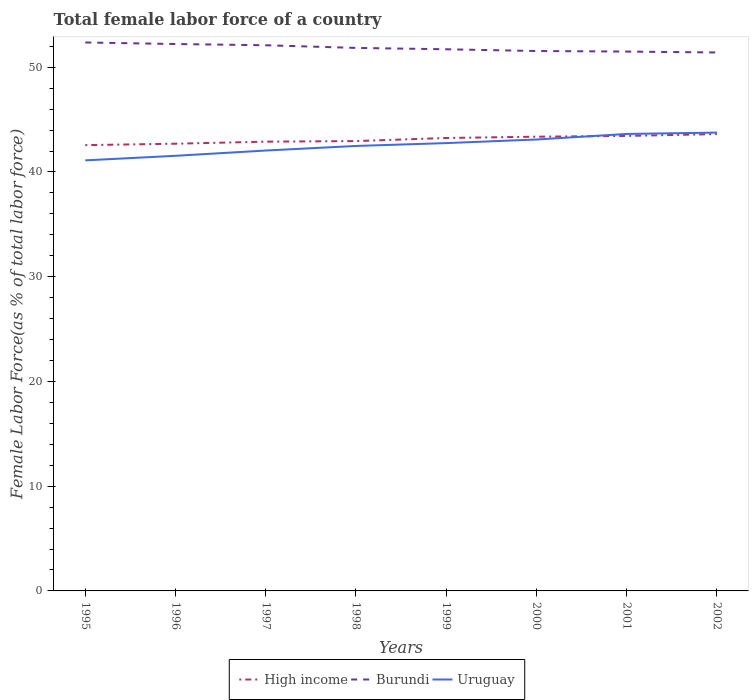How many different coloured lines are there?
Your response must be concise. 3. Does the line corresponding to Uruguay intersect with the line corresponding to High income?
Offer a very short reply. Yes. Across all years, what is the maximum percentage of female labor force in Uruguay?
Your answer should be very brief. 41.11. In which year was the percentage of female labor force in Uruguay maximum?
Offer a terse response. 1995. What is the total percentage of female labor force in High income in the graph?
Offer a terse response. -0.55. What is the difference between the highest and the second highest percentage of female labor force in Burundi?
Ensure brevity in your answer.  0.96. What is the difference between the highest and the lowest percentage of female labor force in Burundi?
Offer a very short reply. 4. Is the percentage of female labor force in Burundi strictly greater than the percentage of female labor force in Uruguay over the years?
Ensure brevity in your answer.  No. How many years are there in the graph?
Your response must be concise. 8. Are the values on the major ticks of Y-axis written in scientific E-notation?
Keep it short and to the point. No. Where does the legend appear in the graph?
Keep it short and to the point. Bottom center. How are the legend labels stacked?
Provide a short and direct response. Horizontal. What is the title of the graph?
Your answer should be compact. Total female labor force of a country. What is the label or title of the Y-axis?
Offer a terse response. Female Labor Force(as % of total labor force). What is the Female Labor Force(as % of total labor force) of High income in 1995?
Offer a very short reply. 42.57. What is the Female Labor Force(as % of total labor force) of Burundi in 1995?
Keep it short and to the point. 52.37. What is the Female Labor Force(as % of total labor force) in Uruguay in 1995?
Give a very brief answer. 41.11. What is the Female Labor Force(as % of total labor force) in High income in 1996?
Offer a very short reply. 42.7. What is the Female Labor Force(as % of total labor force) of Burundi in 1996?
Offer a very short reply. 52.22. What is the Female Labor Force(as % of total labor force) in Uruguay in 1996?
Keep it short and to the point. 41.55. What is the Female Labor Force(as % of total labor force) of High income in 1997?
Offer a terse response. 42.9. What is the Female Labor Force(as % of total labor force) in Burundi in 1997?
Provide a short and direct response. 52.1. What is the Female Labor Force(as % of total labor force) in Uruguay in 1997?
Offer a very short reply. 42.05. What is the Female Labor Force(as % of total labor force) in High income in 1998?
Your answer should be very brief. 42.95. What is the Female Labor Force(as % of total labor force) of Burundi in 1998?
Ensure brevity in your answer.  51.85. What is the Female Labor Force(as % of total labor force) of Uruguay in 1998?
Make the answer very short. 42.49. What is the Female Labor Force(as % of total labor force) of High income in 1999?
Offer a terse response. 43.25. What is the Female Labor Force(as % of total labor force) in Burundi in 1999?
Ensure brevity in your answer.  51.72. What is the Female Labor Force(as % of total labor force) of Uruguay in 1999?
Your answer should be compact. 42.76. What is the Female Labor Force(as % of total labor force) of High income in 2000?
Make the answer very short. 43.37. What is the Female Labor Force(as % of total labor force) in Burundi in 2000?
Provide a short and direct response. 51.55. What is the Female Labor Force(as % of total labor force) of Uruguay in 2000?
Provide a succinct answer. 43.1. What is the Female Labor Force(as % of total labor force) of High income in 2001?
Give a very brief answer. 43.44. What is the Female Labor Force(as % of total labor force) of Burundi in 2001?
Provide a short and direct response. 51.5. What is the Female Labor Force(as % of total labor force) in Uruguay in 2001?
Give a very brief answer. 43.63. What is the Female Labor Force(as % of total labor force) of High income in 2002?
Your answer should be very brief. 43.62. What is the Female Labor Force(as % of total labor force) of Burundi in 2002?
Offer a terse response. 51.41. What is the Female Labor Force(as % of total labor force) of Uruguay in 2002?
Offer a terse response. 43.76. Across all years, what is the maximum Female Labor Force(as % of total labor force) of High income?
Your answer should be very brief. 43.62. Across all years, what is the maximum Female Labor Force(as % of total labor force) in Burundi?
Your answer should be compact. 52.37. Across all years, what is the maximum Female Labor Force(as % of total labor force) in Uruguay?
Make the answer very short. 43.76. Across all years, what is the minimum Female Labor Force(as % of total labor force) in High income?
Offer a terse response. 42.57. Across all years, what is the minimum Female Labor Force(as % of total labor force) in Burundi?
Your answer should be compact. 51.41. Across all years, what is the minimum Female Labor Force(as % of total labor force) in Uruguay?
Your response must be concise. 41.11. What is the total Female Labor Force(as % of total labor force) of High income in the graph?
Make the answer very short. 344.8. What is the total Female Labor Force(as % of total labor force) in Burundi in the graph?
Provide a short and direct response. 414.72. What is the total Female Labor Force(as % of total labor force) of Uruguay in the graph?
Ensure brevity in your answer.  340.45. What is the difference between the Female Labor Force(as % of total labor force) in High income in 1995 and that in 1996?
Make the answer very short. -0.14. What is the difference between the Female Labor Force(as % of total labor force) of Burundi in 1995 and that in 1996?
Provide a short and direct response. 0.15. What is the difference between the Female Labor Force(as % of total labor force) of Uruguay in 1995 and that in 1996?
Offer a very short reply. -0.44. What is the difference between the Female Labor Force(as % of total labor force) in High income in 1995 and that in 1997?
Provide a short and direct response. -0.33. What is the difference between the Female Labor Force(as % of total labor force) in Burundi in 1995 and that in 1997?
Provide a succinct answer. 0.27. What is the difference between the Female Labor Force(as % of total labor force) of Uruguay in 1995 and that in 1997?
Provide a short and direct response. -0.94. What is the difference between the Female Labor Force(as % of total labor force) in High income in 1995 and that in 1998?
Provide a short and direct response. -0.39. What is the difference between the Female Labor Force(as % of total labor force) in Burundi in 1995 and that in 1998?
Provide a succinct answer. 0.52. What is the difference between the Female Labor Force(as % of total labor force) of Uruguay in 1995 and that in 1998?
Offer a very short reply. -1.38. What is the difference between the Female Labor Force(as % of total labor force) in High income in 1995 and that in 1999?
Offer a very short reply. -0.68. What is the difference between the Female Labor Force(as % of total labor force) of Burundi in 1995 and that in 1999?
Keep it short and to the point. 0.65. What is the difference between the Female Labor Force(as % of total labor force) in Uruguay in 1995 and that in 1999?
Provide a short and direct response. -1.65. What is the difference between the Female Labor Force(as % of total labor force) of High income in 1995 and that in 2000?
Make the answer very short. -0.81. What is the difference between the Female Labor Force(as % of total labor force) of Burundi in 1995 and that in 2000?
Offer a terse response. 0.82. What is the difference between the Female Labor Force(as % of total labor force) in Uruguay in 1995 and that in 2000?
Make the answer very short. -1.99. What is the difference between the Female Labor Force(as % of total labor force) in High income in 1995 and that in 2001?
Keep it short and to the point. -0.88. What is the difference between the Female Labor Force(as % of total labor force) of Burundi in 1995 and that in 2001?
Ensure brevity in your answer.  0.87. What is the difference between the Female Labor Force(as % of total labor force) of Uruguay in 1995 and that in 2001?
Provide a short and direct response. -2.52. What is the difference between the Female Labor Force(as % of total labor force) in High income in 1995 and that in 2002?
Offer a terse response. -1.05. What is the difference between the Female Labor Force(as % of total labor force) of Burundi in 1995 and that in 2002?
Keep it short and to the point. 0.96. What is the difference between the Female Labor Force(as % of total labor force) in Uruguay in 1995 and that in 2002?
Keep it short and to the point. -2.65. What is the difference between the Female Labor Force(as % of total labor force) in High income in 1996 and that in 1997?
Offer a terse response. -0.2. What is the difference between the Female Labor Force(as % of total labor force) in Burundi in 1996 and that in 1997?
Make the answer very short. 0.12. What is the difference between the Female Labor Force(as % of total labor force) in Uruguay in 1996 and that in 1997?
Your answer should be compact. -0.5. What is the difference between the Female Labor Force(as % of total labor force) in High income in 1996 and that in 1998?
Make the answer very short. -0.25. What is the difference between the Female Labor Force(as % of total labor force) of Burundi in 1996 and that in 1998?
Offer a very short reply. 0.37. What is the difference between the Female Labor Force(as % of total labor force) of Uruguay in 1996 and that in 1998?
Offer a very short reply. -0.94. What is the difference between the Female Labor Force(as % of total labor force) in High income in 1996 and that in 1999?
Offer a terse response. -0.55. What is the difference between the Female Labor Force(as % of total labor force) in Burundi in 1996 and that in 1999?
Your answer should be very brief. 0.5. What is the difference between the Female Labor Force(as % of total labor force) in Uruguay in 1996 and that in 1999?
Offer a very short reply. -1.21. What is the difference between the Female Labor Force(as % of total labor force) in High income in 1996 and that in 2000?
Ensure brevity in your answer.  -0.67. What is the difference between the Female Labor Force(as % of total labor force) of Burundi in 1996 and that in 2000?
Your answer should be very brief. 0.67. What is the difference between the Female Labor Force(as % of total labor force) in Uruguay in 1996 and that in 2000?
Offer a terse response. -1.56. What is the difference between the Female Labor Force(as % of total labor force) in High income in 1996 and that in 2001?
Your answer should be very brief. -0.74. What is the difference between the Female Labor Force(as % of total labor force) of Burundi in 1996 and that in 2001?
Your response must be concise. 0.72. What is the difference between the Female Labor Force(as % of total labor force) in Uruguay in 1996 and that in 2001?
Provide a succinct answer. -2.09. What is the difference between the Female Labor Force(as % of total labor force) of High income in 1996 and that in 2002?
Ensure brevity in your answer.  -0.92. What is the difference between the Female Labor Force(as % of total labor force) in Burundi in 1996 and that in 2002?
Your answer should be very brief. 0.81. What is the difference between the Female Labor Force(as % of total labor force) of Uruguay in 1996 and that in 2002?
Give a very brief answer. -2.22. What is the difference between the Female Labor Force(as % of total labor force) of High income in 1997 and that in 1998?
Your answer should be compact. -0.06. What is the difference between the Female Labor Force(as % of total labor force) of Burundi in 1997 and that in 1998?
Your answer should be compact. 0.25. What is the difference between the Female Labor Force(as % of total labor force) of Uruguay in 1997 and that in 1998?
Provide a succinct answer. -0.44. What is the difference between the Female Labor Force(as % of total labor force) in High income in 1997 and that in 1999?
Keep it short and to the point. -0.35. What is the difference between the Female Labor Force(as % of total labor force) in Burundi in 1997 and that in 1999?
Give a very brief answer. 0.38. What is the difference between the Female Labor Force(as % of total labor force) of Uruguay in 1997 and that in 1999?
Your answer should be compact. -0.71. What is the difference between the Female Labor Force(as % of total labor force) in High income in 1997 and that in 2000?
Ensure brevity in your answer.  -0.47. What is the difference between the Female Labor Force(as % of total labor force) in Burundi in 1997 and that in 2000?
Make the answer very short. 0.55. What is the difference between the Female Labor Force(as % of total labor force) in Uruguay in 1997 and that in 2000?
Provide a short and direct response. -1.05. What is the difference between the Female Labor Force(as % of total labor force) of High income in 1997 and that in 2001?
Provide a succinct answer. -0.55. What is the difference between the Female Labor Force(as % of total labor force) of Burundi in 1997 and that in 2001?
Ensure brevity in your answer.  0.6. What is the difference between the Female Labor Force(as % of total labor force) of Uruguay in 1997 and that in 2001?
Provide a succinct answer. -1.58. What is the difference between the Female Labor Force(as % of total labor force) in High income in 1997 and that in 2002?
Provide a short and direct response. -0.72. What is the difference between the Female Labor Force(as % of total labor force) of Burundi in 1997 and that in 2002?
Provide a short and direct response. 0.69. What is the difference between the Female Labor Force(as % of total labor force) in Uruguay in 1997 and that in 2002?
Give a very brief answer. -1.71. What is the difference between the Female Labor Force(as % of total labor force) of High income in 1998 and that in 1999?
Your answer should be compact. -0.3. What is the difference between the Female Labor Force(as % of total labor force) in Burundi in 1998 and that in 1999?
Offer a very short reply. 0.13. What is the difference between the Female Labor Force(as % of total labor force) in Uruguay in 1998 and that in 1999?
Offer a terse response. -0.27. What is the difference between the Female Labor Force(as % of total labor force) of High income in 1998 and that in 2000?
Your answer should be very brief. -0.42. What is the difference between the Female Labor Force(as % of total labor force) of Burundi in 1998 and that in 2000?
Your answer should be very brief. 0.3. What is the difference between the Female Labor Force(as % of total labor force) of Uruguay in 1998 and that in 2000?
Your response must be concise. -0.62. What is the difference between the Female Labor Force(as % of total labor force) in High income in 1998 and that in 2001?
Offer a very short reply. -0.49. What is the difference between the Female Labor Force(as % of total labor force) of Burundi in 1998 and that in 2001?
Offer a terse response. 0.35. What is the difference between the Female Labor Force(as % of total labor force) of Uruguay in 1998 and that in 2001?
Provide a short and direct response. -1.15. What is the difference between the Female Labor Force(as % of total labor force) in High income in 1998 and that in 2002?
Provide a short and direct response. -0.67. What is the difference between the Female Labor Force(as % of total labor force) in Burundi in 1998 and that in 2002?
Provide a short and direct response. 0.44. What is the difference between the Female Labor Force(as % of total labor force) of Uruguay in 1998 and that in 2002?
Your response must be concise. -1.28. What is the difference between the Female Labor Force(as % of total labor force) in High income in 1999 and that in 2000?
Keep it short and to the point. -0.12. What is the difference between the Female Labor Force(as % of total labor force) of Burundi in 1999 and that in 2000?
Offer a very short reply. 0.17. What is the difference between the Female Labor Force(as % of total labor force) in Uruguay in 1999 and that in 2000?
Keep it short and to the point. -0.34. What is the difference between the Female Labor Force(as % of total labor force) of High income in 1999 and that in 2001?
Your answer should be compact. -0.2. What is the difference between the Female Labor Force(as % of total labor force) in Burundi in 1999 and that in 2001?
Provide a short and direct response. 0.22. What is the difference between the Female Labor Force(as % of total labor force) in Uruguay in 1999 and that in 2001?
Provide a succinct answer. -0.87. What is the difference between the Female Labor Force(as % of total labor force) in High income in 1999 and that in 2002?
Your response must be concise. -0.37. What is the difference between the Female Labor Force(as % of total labor force) in Burundi in 1999 and that in 2002?
Your answer should be very brief. 0.31. What is the difference between the Female Labor Force(as % of total labor force) of Uruguay in 1999 and that in 2002?
Keep it short and to the point. -1. What is the difference between the Female Labor Force(as % of total labor force) in High income in 2000 and that in 2001?
Your response must be concise. -0.07. What is the difference between the Female Labor Force(as % of total labor force) of Burundi in 2000 and that in 2001?
Give a very brief answer. 0.05. What is the difference between the Female Labor Force(as % of total labor force) in Uruguay in 2000 and that in 2001?
Your response must be concise. -0.53. What is the difference between the Female Labor Force(as % of total labor force) in High income in 2000 and that in 2002?
Your answer should be compact. -0.25. What is the difference between the Female Labor Force(as % of total labor force) in Burundi in 2000 and that in 2002?
Provide a short and direct response. 0.14. What is the difference between the Female Labor Force(as % of total labor force) of Uruguay in 2000 and that in 2002?
Provide a succinct answer. -0.66. What is the difference between the Female Labor Force(as % of total labor force) in High income in 2001 and that in 2002?
Your answer should be very brief. -0.18. What is the difference between the Female Labor Force(as % of total labor force) in Burundi in 2001 and that in 2002?
Offer a terse response. 0.09. What is the difference between the Female Labor Force(as % of total labor force) in Uruguay in 2001 and that in 2002?
Your answer should be very brief. -0.13. What is the difference between the Female Labor Force(as % of total labor force) in High income in 1995 and the Female Labor Force(as % of total labor force) in Burundi in 1996?
Provide a succinct answer. -9.65. What is the difference between the Female Labor Force(as % of total labor force) in High income in 1995 and the Female Labor Force(as % of total labor force) in Uruguay in 1996?
Give a very brief answer. 1.02. What is the difference between the Female Labor Force(as % of total labor force) in Burundi in 1995 and the Female Labor Force(as % of total labor force) in Uruguay in 1996?
Your answer should be very brief. 10.82. What is the difference between the Female Labor Force(as % of total labor force) of High income in 1995 and the Female Labor Force(as % of total labor force) of Burundi in 1997?
Make the answer very short. -9.54. What is the difference between the Female Labor Force(as % of total labor force) of High income in 1995 and the Female Labor Force(as % of total labor force) of Uruguay in 1997?
Ensure brevity in your answer.  0.52. What is the difference between the Female Labor Force(as % of total labor force) in Burundi in 1995 and the Female Labor Force(as % of total labor force) in Uruguay in 1997?
Provide a short and direct response. 10.32. What is the difference between the Female Labor Force(as % of total labor force) of High income in 1995 and the Female Labor Force(as % of total labor force) of Burundi in 1998?
Keep it short and to the point. -9.28. What is the difference between the Female Labor Force(as % of total labor force) of High income in 1995 and the Female Labor Force(as % of total labor force) of Uruguay in 1998?
Offer a terse response. 0.08. What is the difference between the Female Labor Force(as % of total labor force) in Burundi in 1995 and the Female Labor Force(as % of total labor force) in Uruguay in 1998?
Keep it short and to the point. 9.88. What is the difference between the Female Labor Force(as % of total labor force) of High income in 1995 and the Female Labor Force(as % of total labor force) of Burundi in 1999?
Keep it short and to the point. -9.15. What is the difference between the Female Labor Force(as % of total labor force) of High income in 1995 and the Female Labor Force(as % of total labor force) of Uruguay in 1999?
Give a very brief answer. -0.19. What is the difference between the Female Labor Force(as % of total labor force) in Burundi in 1995 and the Female Labor Force(as % of total labor force) in Uruguay in 1999?
Your answer should be very brief. 9.61. What is the difference between the Female Labor Force(as % of total labor force) in High income in 1995 and the Female Labor Force(as % of total labor force) in Burundi in 2000?
Provide a short and direct response. -8.99. What is the difference between the Female Labor Force(as % of total labor force) of High income in 1995 and the Female Labor Force(as % of total labor force) of Uruguay in 2000?
Your answer should be very brief. -0.54. What is the difference between the Female Labor Force(as % of total labor force) of Burundi in 1995 and the Female Labor Force(as % of total labor force) of Uruguay in 2000?
Offer a very short reply. 9.26. What is the difference between the Female Labor Force(as % of total labor force) in High income in 1995 and the Female Labor Force(as % of total labor force) in Burundi in 2001?
Ensure brevity in your answer.  -8.93. What is the difference between the Female Labor Force(as % of total labor force) in High income in 1995 and the Female Labor Force(as % of total labor force) in Uruguay in 2001?
Provide a succinct answer. -1.07. What is the difference between the Female Labor Force(as % of total labor force) in Burundi in 1995 and the Female Labor Force(as % of total labor force) in Uruguay in 2001?
Ensure brevity in your answer.  8.73. What is the difference between the Female Labor Force(as % of total labor force) of High income in 1995 and the Female Labor Force(as % of total labor force) of Burundi in 2002?
Your response must be concise. -8.85. What is the difference between the Female Labor Force(as % of total labor force) in High income in 1995 and the Female Labor Force(as % of total labor force) in Uruguay in 2002?
Make the answer very short. -1.2. What is the difference between the Female Labor Force(as % of total labor force) in Burundi in 1995 and the Female Labor Force(as % of total labor force) in Uruguay in 2002?
Provide a short and direct response. 8.61. What is the difference between the Female Labor Force(as % of total labor force) in High income in 1996 and the Female Labor Force(as % of total labor force) in Burundi in 1997?
Keep it short and to the point. -9.4. What is the difference between the Female Labor Force(as % of total labor force) in High income in 1996 and the Female Labor Force(as % of total labor force) in Uruguay in 1997?
Your answer should be very brief. 0.65. What is the difference between the Female Labor Force(as % of total labor force) of Burundi in 1996 and the Female Labor Force(as % of total labor force) of Uruguay in 1997?
Your answer should be very brief. 10.17. What is the difference between the Female Labor Force(as % of total labor force) in High income in 1996 and the Female Labor Force(as % of total labor force) in Burundi in 1998?
Offer a terse response. -9.15. What is the difference between the Female Labor Force(as % of total labor force) of High income in 1996 and the Female Labor Force(as % of total labor force) of Uruguay in 1998?
Your response must be concise. 0.21. What is the difference between the Female Labor Force(as % of total labor force) of Burundi in 1996 and the Female Labor Force(as % of total labor force) of Uruguay in 1998?
Keep it short and to the point. 9.73. What is the difference between the Female Labor Force(as % of total labor force) of High income in 1996 and the Female Labor Force(as % of total labor force) of Burundi in 1999?
Offer a very short reply. -9.02. What is the difference between the Female Labor Force(as % of total labor force) in High income in 1996 and the Female Labor Force(as % of total labor force) in Uruguay in 1999?
Your answer should be compact. -0.06. What is the difference between the Female Labor Force(as % of total labor force) of Burundi in 1996 and the Female Labor Force(as % of total labor force) of Uruguay in 1999?
Your answer should be very brief. 9.46. What is the difference between the Female Labor Force(as % of total labor force) in High income in 1996 and the Female Labor Force(as % of total labor force) in Burundi in 2000?
Ensure brevity in your answer.  -8.85. What is the difference between the Female Labor Force(as % of total labor force) in High income in 1996 and the Female Labor Force(as % of total labor force) in Uruguay in 2000?
Offer a very short reply. -0.4. What is the difference between the Female Labor Force(as % of total labor force) of Burundi in 1996 and the Female Labor Force(as % of total labor force) of Uruguay in 2000?
Ensure brevity in your answer.  9.12. What is the difference between the Female Labor Force(as % of total labor force) in High income in 1996 and the Female Labor Force(as % of total labor force) in Burundi in 2001?
Your answer should be very brief. -8.8. What is the difference between the Female Labor Force(as % of total labor force) of High income in 1996 and the Female Labor Force(as % of total labor force) of Uruguay in 2001?
Make the answer very short. -0.93. What is the difference between the Female Labor Force(as % of total labor force) in Burundi in 1996 and the Female Labor Force(as % of total labor force) in Uruguay in 2001?
Your answer should be very brief. 8.59. What is the difference between the Female Labor Force(as % of total labor force) in High income in 1996 and the Female Labor Force(as % of total labor force) in Burundi in 2002?
Offer a very short reply. -8.71. What is the difference between the Female Labor Force(as % of total labor force) in High income in 1996 and the Female Labor Force(as % of total labor force) in Uruguay in 2002?
Ensure brevity in your answer.  -1.06. What is the difference between the Female Labor Force(as % of total labor force) in Burundi in 1996 and the Female Labor Force(as % of total labor force) in Uruguay in 2002?
Provide a succinct answer. 8.46. What is the difference between the Female Labor Force(as % of total labor force) of High income in 1997 and the Female Labor Force(as % of total labor force) of Burundi in 1998?
Keep it short and to the point. -8.95. What is the difference between the Female Labor Force(as % of total labor force) of High income in 1997 and the Female Labor Force(as % of total labor force) of Uruguay in 1998?
Your response must be concise. 0.41. What is the difference between the Female Labor Force(as % of total labor force) of Burundi in 1997 and the Female Labor Force(as % of total labor force) of Uruguay in 1998?
Make the answer very short. 9.62. What is the difference between the Female Labor Force(as % of total labor force) of High income in 1997 and the Female Labor Force(as % of total labor force) of Burundi in 1999?
Provide a short and direct response. -8.82. What is the difference between the Female Labor Force(as % of total labor force) of High income in 1997 and the Female Labor Force(as % of total labor force) of Uruguay in 1999?
Give a very brief answer. 0.14. What is the difference between the Female Labor Force(as % of total labor force) in Burundi in 1997 and the Female Labor Force(as % of total labor force) in Uruguay in 1999?
Offer a terse response. 9.34. What is the difference between the Female Labor Force(as % of total labor force) in High income in 1997 and the Female Labor Force(as % of total labor force) in Burundi in 2000?
Make the answer very short. -8.66. What is the difference between the Female Labor Force(as % of total labor force) of High income in 1997 and the Female Labor Force(as % of total labor force) of Uruguay in 2000?
Provide a short and direct response. -0.21. What is the difference between the Female Labor Force(as % of total labor force) of Burundi in 1997 and the Female Labor Force(as % of total labor force) of Uruguay in 2000?
Make the answer very short. 9. What is the difference between the Female Labor Force(as % of total labor force) in High income in 1997 and the Female Labor Force(as % of total labor force) in Burundi in 2001?
Offer a very short reply. -8.6. What is the difference between the Female Labor Force(as % of total labor force) in High income in 1997 and the Female Labor Force(as % of total labor force) in Uruguay in 2001?
Your response must be concise. -0.74. What is the difference between the Female Labor Force(as % of total labor force) of Burundi in 1997 and the Female Labor Force(as % of total labor force) of Uruguay in 2001?
Give a very brief answer. 8.47. What is the difference between the Female Labor Force(as % of total labor force) in High income in 1997 and the Female Labor Force(as % of total labor force) in Burundi in 2002?
Your answer should be compact. -8.51. What is the difference between the Female Labor Force(as % of total labor force) of High income in 1997 and the Female Labor Force(as % of total labor force) of Uruguay in 2002?
Provide a short and direct response. -0.87. What is the difference between the Female Labor Force(as % of total labor force) of Burundi in 1997 and the Female Labor Force(as % of total labor force) of Uruguay in 2002?
Provide a succinct answer. 8.34. What is the difference between the Female Labor Force(as % of total labor force) of High income in 1998 and the Female Labor Force(as % of total labor force) of Burundi in 1999?
Provide a short and direct response. -8.77. What is the difference between the Female Labor Force(as % of total labor force) in High income in 1998 and the Female Labor Force(as % of total labor force) in Uruguay in 1999?
Make the answer very short. 0.19. What is the difference between the Female Labor Force(as % of total labor force) of Burundi in 1998 and the Female Labor Force(as % of total labor force) of Uruguay in 1999?
Provide a short and direct response. 9.09. What is the difference between the Female Labor Force(as % of total labor force) in High income in 1998 and the Female Labor Force(as % of total labor force) in Burundi in 2000?
Keep it short and to the point. -8.6. What is the difference between the Female Labor Force(as % of total labor force) in High income in 1998 and the Female Labor Force(as % of total labor force) in Uruguay in 2000?
Offer a very short reply. -0.15. What is the difference between the Female Labor Force(as % of total labor force) of Burundi in 1998 and the Female Labor Force(as % of total labor force) of Uruguay in 2000?
Ensure brevity in your answer.  8.74. What is the difference between the Female Labor Force(as % of total labor force) of High income in 1998 and the Female Labor Force(as % of total labor force) of Burundi in 2001?
Your response must be concise. -8.55. What is the difference between the Female Labor Force(as % of total labor force) of High income in 1998 and the Female Labor Force(as % of total labor force) of Uruguay in 2001?
Make the answer very short. -0.68. What is the difference between the Female Labor Force(as % of total labor force) in Burundi in 1998 and the Female Labor Force(as % of total labor force) in Uruguay in 2001?
Provide a short and direct response. 8.21. What is the difference between the Female Labor Force(as % of total labor force) of High income in 1998 and the Female Labor Force(as % of total labor force) of Burundi in 2002?
Provide a short and direct response. -8.46. What is the difference between the Female Labor Force(as % of total labor force) in High income in 1998 and the Female Labor Force(as % of total labor force) in Uruguay in 2002?
Give a very brief answer. -0.81. What is the difference between the Female Labor Force(as % of total labor force) of Burundi in 1998 and the Female Labor Force(as % of total labor force) of Uruguay in 2002?
Give a very brief answer. 8.09. What is the difference between the Female Labor Force(as % of total labor force) of High income in 1999 and the Female Labor Force(as % of total labor force) of Burundi in 2000?
Your response must be concise. -8.3. What is the difference between the Female Labor Force(as % of total labor force) of High income in 1999 and the Female Labor Force(as % of total labor force) of Uruguay in 2000?
Your response must be concise. 0.15. What is the difference between the Female Labor Force(as % of total labor force) in Burundi in 1999 and the Female Labor Force(as % of total labor force) in Uruguay in 2000?
Your answer should be very brief. 8.62. What is the difference between the Female Labor Force(as % of total labor force) in High income in 1999 and the Female Labor Force(as % of total labor force) in Burundi in 2001?
Ensure brevity in your answer.  -8.25. What is the difference between the Female Labor Force(as % of total labor force) in High income in 1999 and the Female Labor Force(as % of total labor force) in Uruguay in 2001?
Your answer should be very brief. -0.38. What is the difference between the Female Labor Force(as % of total labor force) of Burundi in 1999 and the Female Labor Force(as % of total labor force) of Uruguay in 2001?
Provide a succinct answer. 8.09. What is the difference between the Female Labor Force(as % of total labor force) in High income in 1999 and the Female Labor Force(as % of total labor force) in Burundi in 2002?
Provide a succinct answer. -8.16. What is the difference between the Female Labor Force(as % of total labor force) in High income in 1999 and the Female Labor Force(as % of total labor force) in Uruguay in 2002?
Your response must be concise. -0.51. What is the difference between the Female Labor Force(as % of total labor force) in Burundi in 1999 and the Female Labor Force(as % of total labor force) in Uruguay in 2002?
Your response must be concise. 7.96. What is the difference between the Female Labor Force(as % of total labor force) of High income in 2000 and the Female Labor Force(as % of total labor force) of Burundi in 2001?
Provide a short and direct response. -8.13. What is the difference between the Female Labor Force(as % of total labor force) in High income in 2000 and the Female Labor Force(as % of total labor force) in Uruguay in 2001?
Give a very brief answer. -0.26. What is the difference between the Female Labor Force(as % of total labor force) in Burundi in 2000 and the Female Labor Force(as % of total labor force) in Uruguay in 2001?
Keep it short and to the point. 7.92. What is the difference between the Female Labor Force(as % of total labor force) in High income in 2000 and the Female Labor Force(as % of total labor force) in Burundi in 2002?
Your answer should be very brief. -8.04. What is the difference between the Female Labor Force(as % of total labor force) of High income in 2000 and the Female Labor Force(as % of total labor force) of Uruguay in 2002?
Provide a succinct answer. -0.39. What is the difference between the Female Labor Force(as % of total labor force) in Burundi in 2000 and the Female Labor Force(as % of total labor force) in Uruguay in 2002?
Give a very brief answer. 7.79. What is the difference between the Female Labor Force(as % of total labor force) of High income in 2001 and the Female Labor Force(as % of total labor force) of Burundi in 2002?
Offer a terse response. -7.97. What is the difference between the Female Labor Force(as % of total labor force) in High income in 2001 and the Female Labor Force(as % of total labor force) in Uruguay in 2002?
Provide a succinct answer. -0.32. What is the difference between the Female Labor Force(as % of total labor force) in Burundi in 2001 and the Female Labor Force(as % of total labor force) in Uruguay in 2002?
Offer a very short reply. 7.74. What is the average Female Labor Force(as % of total labor force) of High income per year?
Your answer should be very brief. 43.1. What is the average Female Labor Force(as % of total labor force) in Burundi per year?
Give a very brief answer. 51.84. What is the average Female Labor Force(as % of total labor force) in Uruguay per year?
Provide a succinct answer. 42.56. In the year 1995, what is the difference between the Female Labor Force(as % of total labor force) in High income and Female Labor Force(as % of total labor force) in Burundi?
Provide a succinct answer. -9.8. In the year 1995, what is the difference between the Female Labor Force(as % of total labor force) in High income and Female Labor Force(as % of total labor force) in Uruguay?
Your answer should be compact. 1.46. In the year 1995, what is the difference between the Female Labor Force(as % of total labor force) of Burundi and Female Labor Force(as % of total labor force) of Uruguay?
Give a very brief answer. 11.26. In the year 1996, what is the difference between the Female Labor Force(as % of total labor force) of High income and Female Labor Force(as % of total labor force) of Burundi?
Offer a very short reply. -9.52. In the year 1996, what is the difference between the Female Labor Force(as % of total labor force) in High income and Female Labor Force(as % of total labor force) in Uruguay?
Give a very brief answer. 1.15. In the year 1996, what is the difference between the Female Labor Force(as % of total labor force) in Burundi and Female Labor Force(as % of total labor force) in Uruguay?
Provide a succinct answer. 10.67. In the year 1997, what is the difference between the Female Labor Force(as % of total labor force) in High income and Female Labor Force(as % of total labor force) in Burundi?
Your answer should be very brief. -9.2. In the year 1997, what is the difference between the Female Labor Force(as % of total labor force) in High income and Female Labor Force(as % of total labor force) in Uruguay?
Keep it short and to the point. 0.85. In the year 1997, what is the difference between the Female Labor Force(as % of total labor force) in Burundi and Female Labor Force(as % of total labor force) in Uruguay?
Make the answer very short. 10.05. In the year 1998, what is the difference between the Female Labor Force(as % of total labor force) in High income and Female Labor Force(as % of total labor force) in Burundi?
Ensure brevity in your answer.  -8.9. In the year 1998, what is the difference between the Female Labor Force(as % of total labor force) of High income and Female Labor Force(as % of total labor force) of Uruguay?
Provide a short and direct response. 0.47. In the year 1998, what is the difference between the Female Labor Force(as % of total labor force) in Burundi and Female Labor Force(as % of total labor force) in Uruguay?
Offer a very short reply. 9.36. In the year 1999, what is the difference between the Female Labor Force(as % of total labor force) of High income and Female Labor Force(as % of total labor force) of Burundi?
Offer a terse response. -8.47. In the year 1999, what is the difference between the Female Labor Force(as % of total labor force) in High income and Female Labor Force(as % of total labor force) in Uruguay?
Your answer should be compact. 0.49. In the year 1999, what is the difference between the Female Labor Force(as % of total labor force) of Burundi and Female Labor Force(as % of total labor force) of Uruguay?
Provide a succinct answer. 8.96. In the year 2000, what is the difference between the Female Labor Force(as % of total labor force) of High income and Female Labor Force(as % of total labor force) of Burundi?
Provide a short and direct response. -8.18. In the year 2000, what is the difference between the Female Labor Force(as % of total labor force) of High income and Female Labor Force(as % of total labor force) of Uruguay?
Keep it short and to the point. 0.27. In the year 2000, what is the difference between the Female Labor Force(as % of total labor force) of Burundi and Female Labor Force(as % of total labor force) of Uruguay?
Give a very brief answer. 8.45. In the year 2001, what is the difference between the Female Labor Force(as % of total labor force) in High income and Female Labor Force(as % of total labor force) in Burundi?
Keep it short and to the point. -8.06. In the year 2001, what is the difference between the Female Labor Force(as % of total labor force) in High income and Female Labor Force(as % of total labor force) in Uruguay?
Keep it short and to the point. -0.19. In the year 2001, what is the difference between the Female Labor Force(as % of total labor force) of Burundi and Female Labor Force(as % of total labor force) of Uruguay?
Provide a short and direct response. 7.87. In the year 2002, what is the difference between the Female Labor Force(as % of total labor force) of High income and Female Labor Force(as % of total labor force) of Burundi?
Offer a very short reply. -7.79. In the year 2002, what is the difference between the Female Labor Force(as % of total labor force) in High income and Female Labor Force(as % of total labor force) in Uruguay?
Your answer should be very brief. -0.14. In the year 2002, what is the difference between the Female Labor Force(as % of total labor force) of Burundi and Female Labor Force(as % of total labor force) of Uruguay?
Give a very brief answer. 7.65. What is the ratio of the Female Labor Force(as % of total labor force) in High income in 1995 to that in 1996?
Provide a succinct answer. 1. What is the ratio of the Female Labor Force(as % of total labor force) of Uruguay in 1995 to that in 1996?
Make the answer very short. 0.99. What is the ratio of the Female Labor Force(as % of total labor force) in High income in 1995 to that in 1997?
Provide a short and direct response. 0.99. What is the ratio of the Female Labor Force(as % of total labor force) of Uruguay in 1995 to that in 1997?
Provide a succinct answer. 0.98. What is the ratio of the Female Labor Force(as % of total labor force) of High income in 1995 to that in 1998?
Provide a succinct answer. 0.99. What is the ratio of the Female Labor Force(as % of total labor force) in Burundi in 1995 to that in 1998?
Provide a short and direct response. 1.01. What is the ratio of the Female Labor Force(as % of total labor force) of Uruguay in 1995 to that in 1998?
Give a very brief answer. 0.97. What is the ratio of the Female Labor Force(as % of total labor force) in High income in 1995 to that in 1999?
Keep it short and to the point. 0.98. What is the ratio of the Female Labor Force(as % of total labor force) in Burundi in 1995 to that in 1999?
Make the answer very short. 1.01. What is the ratio of the Female Labor Force(as % of total labor force) of Uruguay in 1995 to that in 1999?
Provide a short and direct response. 0.96. What is the ratio of the Female Labor Force(as % of total labor force) in High income in 1995 to that in 2000?
Your answer should be compact. 0.98. What is the ratio of the Female Labor Force(as % of total labor force) of Burundi in 1995 to that in 2000?
Keep it short and to the point. 1.02. What is the ratio of the Female Labor Force(as % of total labor force) in Uruguay in 1995 to that in 2000?
Offer a very short reply. 0.95. What is the ratio of the Female Labor Force(as % of total labor force) in High income in 1995 to that in 2001?
Give a very brief answer. 0.98. What is the ratio of the Female Labor Force(as % of total labor force) in Burundi in 1995 to that in 2001?
Offer a terse response. 1.02. What is the ratio of the Female Labor Force(as % of total labor force) in Uruguay in 1995 to that in 2001?
Provide a short and direct response. 0.94. What is the ratio of the Female Labor Force(as % of total labor force) of High income in 1995 to that in 2002?
Your response must be concise. 0.98. What is the ratio of the Female Labor Force(as % of total labor force) in Burundi in 1995 to that in 2002?
Offer a very short reply. 1.02. What is the ratio of the Female Labor Force(as % of total labor force) of Uruguay in 1995 to that in 2002?
Provide a short and direct response. 0.94. What is the ratio of the Female Labor Force(as % of total labor force) in High income in 1996 to that in 1998?
Make the answer very short. 0.99. What is the ratio of the Female Labor Force(as % of total labor force) in Burundi in 1996 to that in 1998?
Offer a terse response. 1.01. What is the ratio of the Female Labor Force(as % of total labor force) in Uruguay in 1996 to that in 1998?
Keep it short and to the point. 0.98. What is the ratio of the Female Labor Force(as % of total labor force) in High income in 1996 to that in 1999?
Provide a short and direct response. 0.99. What is the ratio of the Female Labor Force(as % of total labor force) in Burundi in 1996 to that in 1999?
Offer a terse response. 1.01. What is the ratio of the Female Labor Force(as % of total labor force) of Uruguay in 1996 to that in 1999?
Give a very brief answer. 0.97. What is the ratio of the Female Labor Force(as % of total labor force) in High income in 1996 to that in 2000?
Provide a succinct answer. 0.98. What is the ratio of the Female Labor Force(as % of total labor force) of Burundi in 1996 to that in 2000?
Ensure brevity in your answer.  1.01. What is the ratio of the Female Labor Force(as % of total labor force) of Uruguay in 1996 to that in 2000?
Give a very brief answer. 0.96. What is the ratio of the Female Labor Force(as % of total labor force) of High income in 1996 to that in 2001?
Offer a terse response. 0.98. What is the ratio of the Female Labor Force(as % of total labor force) in Burundi in 1996 to that in 2001?
Provide a succinct answer. 1.01. What is the ratio of the Female Labor Force(as % of total labor force) of Uruguay in 1996 to that in 2001?
Ensure brevity in your answer.  0.95. What is the ratio of the Female Labor Force(as % of total labor force) in High income in 1996 to that in 2002?
Ensure brevity in your answer.  0.98. What is the ratio of the Female Labor Force(as % of total labor force) in Burundi in 1996 to that in 2002?
Keep it short and to the point. 1.02. What is the ratio of the Female Labor Force(as % of total labor force) in Uruguay in 1996 to that in 2002?
Provide a succinct answer. 0.95. What is the ratio of the Female Labor Force(as % of total labor force) in High income in 1997 to that in 1998?
Your answer should be compact. 1. What is the ratio of the Female Labor Force(as % of total labor force) of Burundi in 1997 to that in 1998?
Give a very brief answer. 1. What is the ratio of the Female Labor Force(as % of total labor force) of Uruguay in 1997 to that in 1998?
Give a very brief answer. 0.99. What is the ratio of the Female Labor Force(as % of total labor force) of Burundi in 1997 to that in 1999?
Your answer should be compact. 1.01. What is the ratio of the Female Labor Force(as % of total labor force) in Uruguay in 1997 to that in 1999?
Keep it short and to the point. 0.98. What is the ratio of the Female Labor Force(as % of total labor force) of High income in 1997 to that in 2000?
Provide a short and direct response. 0.99. What is the ratio of the Female Labor Force(as % of total labor force) of Burundi in 1997 to that in 2000?
Offer a terse response. 1.01. What is the ratio of the Female Labor Force(as % of total labor force) in Uruguay in 1997 to that in 2000?
Provide a succinct answer. 0.98. What is the ratio of the Female Labor Force(as % of total labor force) in High income in 1997 to that in 2001?
Keep it short and to the point. 0.99. What is the ratio of the Female Labor Force(as % of total labor force) of Burundi in 1997 to that in 2001?
Provide a short and direct response. 1.01. What is the ratio of the Female Labor Force(as % of total labor force) of Uruguay in 1997 to that in 2001?
Provide a short and direct response. 0.96. What is the ratio of the Female Labor Force(as % of total labor force) of High income in 1997 to that in 2002?
Your answer should be compact. 0.98. What is the ratio of the Female Labor Force(as % of total labor force) in Burundi in 1997 to that in 2002?
Ensure brevity in your answer.  1.01. What is the ratio of the Female Labor Force(as % of total labor force) of Uruguay in 1997 to that in 2002?
Your answer should be very brief. 0.96. What is the ratio of the Female Labor Force(as % of total labor force) of High income in 1998 to that in 1999?
Your response must be concise. 0.99. What is the ratio of the Female Labor Force(as % of total labor force) of High income in 1998 to that in 2000?
Make the answer very short. 0.99. What is the ratio of the Female Labor Force(as % of total labor force) in Burundi in 1998 to that in 2000?
Ensure brevity in your answer.  1.01. What is the ratio of the Female Labor Force(as % of total labor force) of Uruguay in 1998 to that in 2000?
Your answer should be very brief. 0.99. What is the ratio of the Female Labor Force(as % of total labor force) in High income in 1998 to that in 2001?
Offer a very short reply. 0.99. What is the ratio of the Female Labor Force(as % of total labor force) in Burundi in 1998 to that in 2001?
Make the answer very short. 1.01. What is the ratio of the Female Labor Force(as % of total labor force) of Uruguay in 1998 to that in 2001?
Provide a short and direct response. 0.97. What is the ratio of the Female Labor Force(as % of total labor force) in High income in 1998 to that in 2002?
Provide a short and direct response. 0.98. What is the ratio of the Female Labor Force(as % of total labor force) in Burundi in 1998 to that in 2002?
Ensure brevity in your answer.  1.01. What is the ratio of the Female Labor Force(as % of total labor force) in Uruguay in 1998 to that in 2002?
Ensure brevity in your answer.  0.97. What is the ratio of the Female Labor Force(as % of total labor force) in High income in 1999 to that in 2000?
Your answer should be very brief. 1. What is the ratio of the Female Labor Force(as % of total labor force) in Burundi in 1999 to that in 2000?
Make the answer very short. 1. What is the ratio of the Female Labor Force(as % of total labor force) of Uruguay in 1999 to that in 2000?
Your answer should be very brief. 0.99. What is the ratio of the Female Labor Force(as % of total labor force) of High income in 1999 to that in 2001?
Make the answer very short. 1. What is the ratio of the Female Labor Force(as % of total labor force) in Burundi in 1999 to that in 2001?
Provide a succinct answer. 1. What is the ratio of the Female Labor Force(as % of total labor force) in Uruguay in 1999 to that in 2001?
Give a very brief answer. 0.98. What is the ratio of the Female Labor Force(as % of total labor force) of Burundi in 1999 to that in 2002?
Provide a succinct answer. 1.01. What is the ratio of the Female Labor Force(as % of total labor force) of Uruguay in 1999 to that in 2002?
Provide a short and direct response. 0.98. What is the ratio of the Female Labor Force(as % of total labor force) of Uruguay in 2000 to that in 2001?
Offer a terse response. 0.99. What is the ratio of the Female Labor Force(as % of total labor force) in Burundi in 2000 to that in 2002?
Your answer should be very brief. 1. What is the ratio of the Female Labor Force(as % of total labor force) of Uruguay in 2000 to that in 2002?
Offer a terse response. 0.98. What is the ratio of the Female Labor Force(as % of total labor force) of High income in 2001 to that in 2002?
Ensure brevity in your answer.  1. What is the ratio of the Female Labor Force(as % of total labor force) in Burundi in 2001 to that in 2002?
Provide a short and direct response. 1. What is the difference between the highest and the second highest Female Labor Force(as % of total labor force) in High income?
Your answer should be compact. 0.18. What is the difference between the highest and the second highest Female Labor Force(as % of total labor force) in Burundi?
Your response must be concise. 0.15. What is the difference between the highest and the second highest Female Labor Force(as % of total labor force) of Uruguay?
Provide a short and direct response. 0.13. What is the difference between the highest and the lowest Female Labor Force(as % of total labor force) in High income?
Ensure brevity in your answer.  1.05. What is the difference between the highest and the lowest Female Labor Force(as % of total labor force) in Burundi?
Offer a very short reply. 0.96. What is the difference between the highest and the lowest Female Labor Force(as % of total labor force) of Uruguay?
Offer a very short reply. 2.65. 